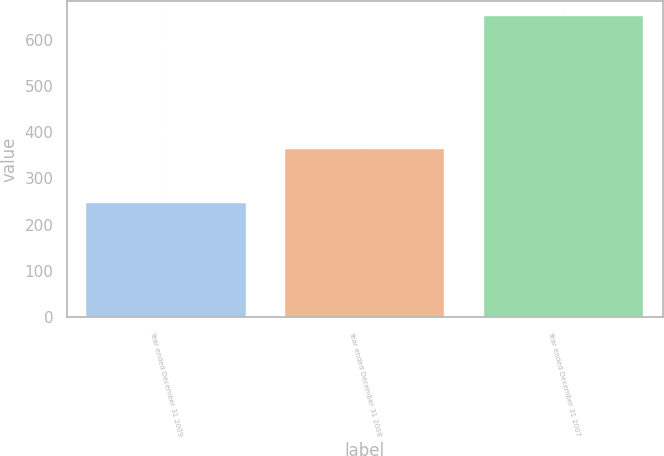<chart> <loc_0><loc_0><loc_500><loc_500><bar_chart><fcel>Year ended December 31 2009<fcel>Year ended December 31 2008<fcel>Year ended December 31 2007<nl><fcel>246<fcel>364<fcel>651<nl></chart> 